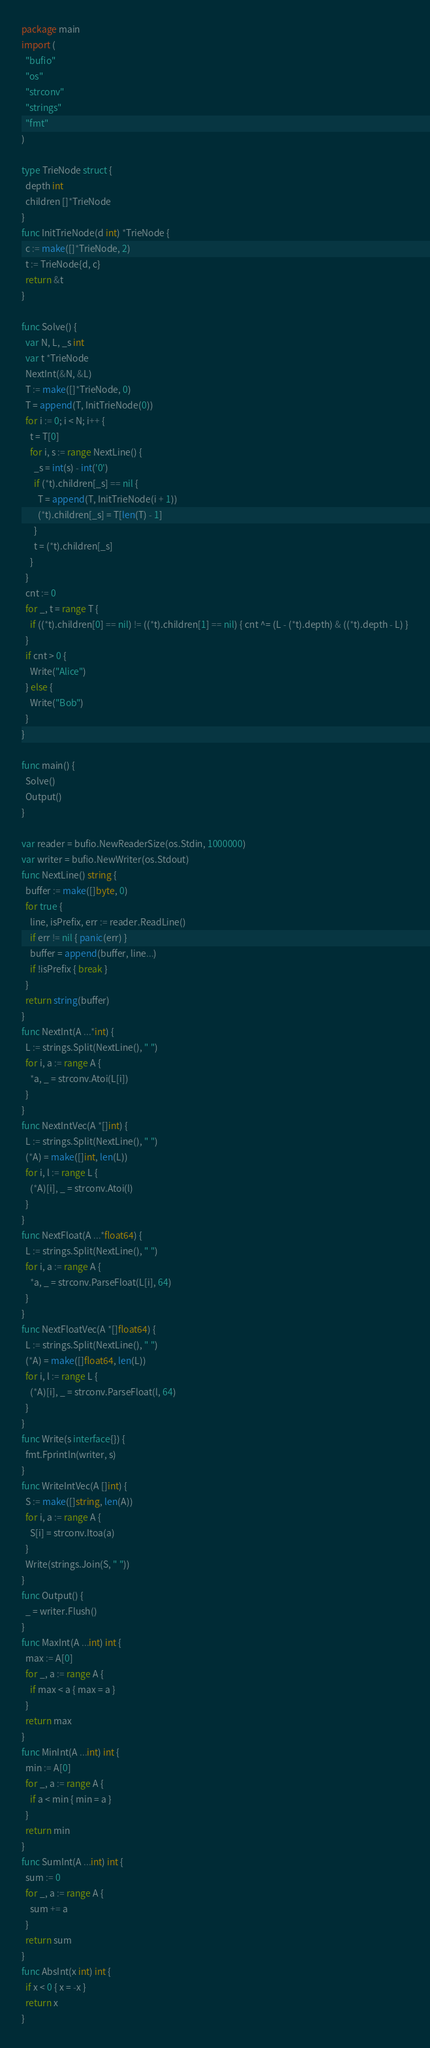Convert code to text. <code><loc_0><loc_0><loc_500><loc_500><_Go_>package main
import (
  "bufio"
  "os"
  "strconv"
  "strings"
  "fmt"
)

type TrieNode struct {
  depth int
  children []*TrieNode
}
func InitTrieNode(d int) *TrieNode {
  c := make([]*TrieNode, 2)
  t := TrieNode{d, c}
  return &t
}

func Solve() {
  var N, L, _s int
  var t *TrieNode
  NextInt(&N, &L)
  T := make([]*TrieNode, 0)
  T = append(T, InitTrieNode(0))
  for i := 0; i < N; i++ {
    t = T[0]
    for i, s := range NextLine() {
      _s = int(s) - int('0')
      if (*t).children[_s] == nil {
        T = append(T, InitTrieNode(i + 1))
        (*t).children[_s] = T[len(T) - 1]
      }
      t = (*t).children[_s]
    }
  }
  cnt := 0
  for _, t = range T {
    if ((*t).children[0] == nil) != ((*t).children[1] == nil) { cnt ^= (L - (*t).depth) & ((*t).depth - L) }
  }
  if cnt > 0 {
    Write("Alice")
  } else {
    Write("Bob")
  }
}

func main() {
  Solve()
  Output()
}

var reader = bufio.NewReaderSize(os.Stdin, 1000000)
var writer = bufio.NewWriter(os.Stdout)
func NextLine() string {
  buffer := make([]byte, 0)
  for true {
    line, isPrefix, err := reader.ReadLine()
    if err != nil { panic(err) }
    buffer = append(buffer, line...)
    if !isPrefix { break }
  }
  return string(buffer)
}
func NextInt(A ...*int) {
  L := strings.Split(NextLine(), " ")
  for i, a := range A {
    *a, _ = strconv.Atoi(L[i])
  }
}
func NextIntVec(A *[]int) {
  L := strings.Split(NextLine(), " ")
  (*A) = make([]int, len(L))
  for i, l := range L {
    (*A)[i], _ = strconv.Atoi(l)
  }
}
func NextFloat(A ...*float64) {
  L := strings.Split(NextLine(), " ")
  for i, a := range A {
    *a, _ = strconv.ParseFloat(L[i], 64)
  }
}
func NextFloatVec(A *[]float64) {
  L := strings.Split(NextLine(), " ")
  (*A) = make([]float64, len(L))
  for i, l := range L {
    (*A)[i], _ = strconv.ParseFloat(l, 64)
  }
}
func Write(s interface{}) {
  fmt.Fprintln(writer, s)
}
func WriteIntVec(A []int) {
  S := make([]string, len(A))
  for i, a := range A {
    S[i] = strconv.Itoa(a)
  }
  Write(strings.Join(S, " "))
}
func Output() {
  _ = writer.Flush()
}
func MaxInt(A ...int) int {
  max := A[0]
  for _, a := range A {
    if max < a { max = a }
  }
  return max
}
func MinInt(A ...int) int {
  min := A[0]
  for _, a := range A {
    if a < min { min = a }
  }
  return min
}
func SumInt(A ...int) int {
  sum := 0
  for _, a := range A {
    sum += a
  }
  return sum
}
func AbsInt(x int) int {
  if x < 0 { x = -x }
  return x
}</code> 